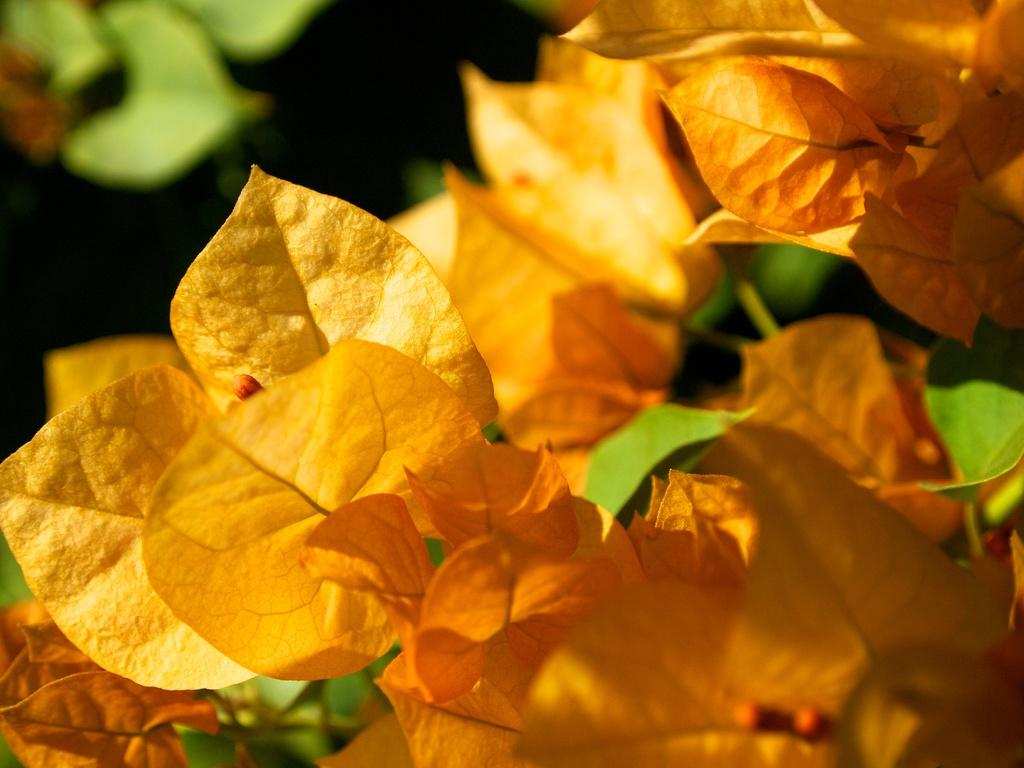What type of vegetation can be seen in the image? There are leaves in the image. Can you see a sponge jumping in the image? There is no sponge or jumping action present in the image; it only features leaves. 